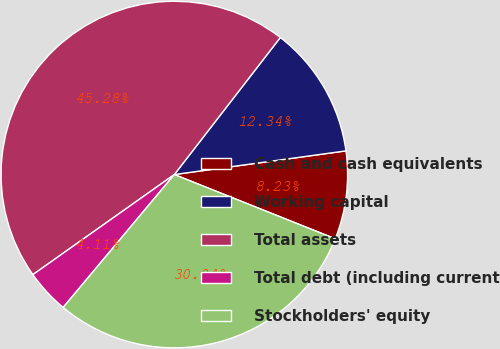Convert chart. <chart><loc_0><loc_0><loc_500><loc_500><pie_chart><fcel>Cash and cash equivalents<fcel>Working capital<fcel>Total assets<fcel>Total debt (including current<fcel>Stockholders' equity<nl><fcel>8.23%<fcel>12.34%<fcel>45.28%<fcel>4.11%<fcel>30.04%<nl></chart> 